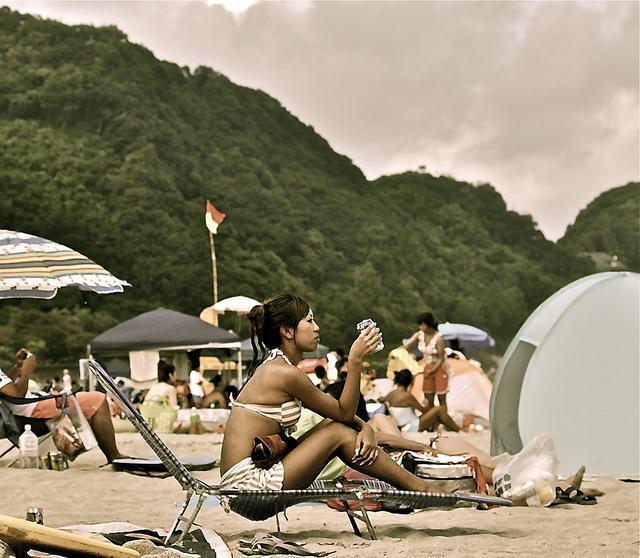How many chairs are in the picture?
Give a very brief answer. 2. How many people are there?
Give a very brief answer. 4. How many umbrellas are there?
Give a very brief answer. 2. 